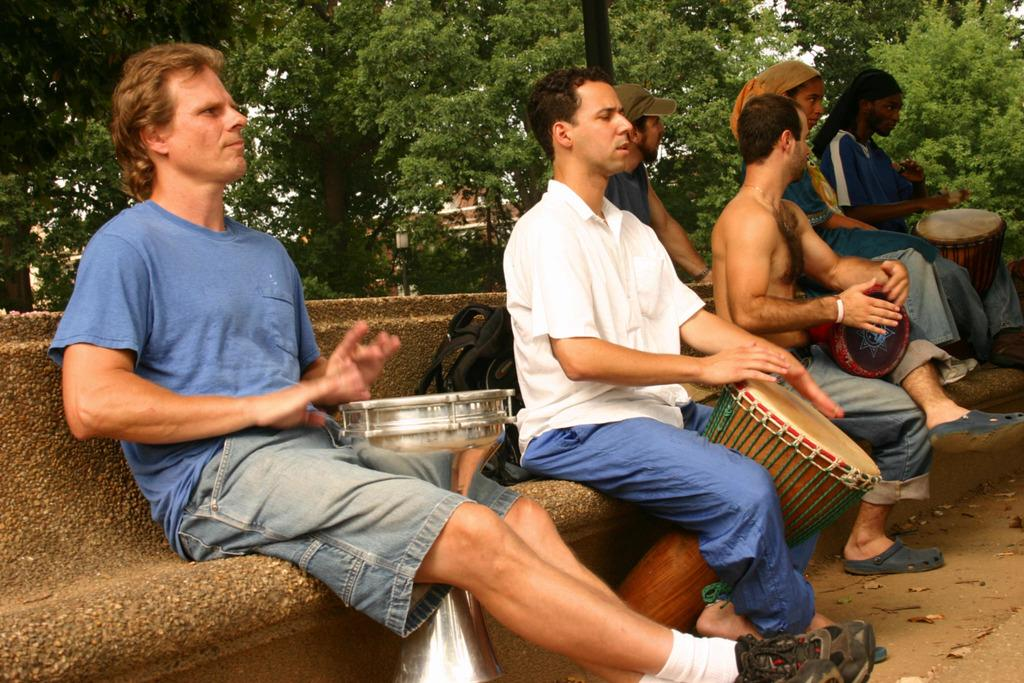What is the main subject of the image? The main subject of the image is a group of men. What are the men in the image doing? The men are sitting and playing drums. What type of copper tramp can be seen in the image? There is no tramp or copper object present in the image. 